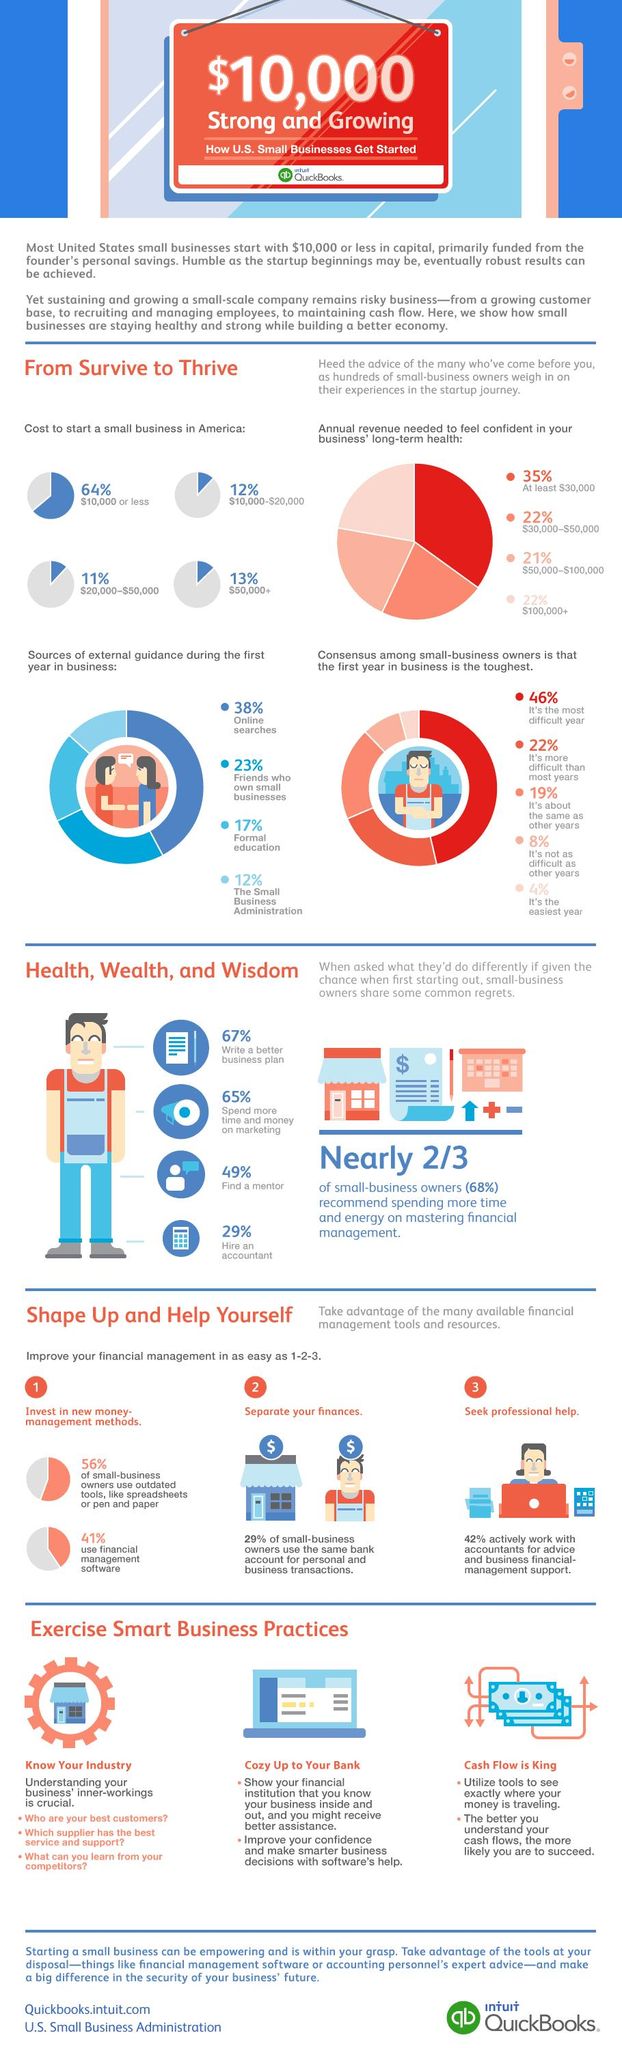Mention a couple of crucial points in this snapshot. Around 12% of businesses require funding between $10,000 and $20,000 to start. Improving your financial management requires taking the second step, which is to separate your finances. A significant percentage of business needs between $10,000 and $50,000 are required to start a business. In the study, it was found that friends who have their own small business often act as sources of external guidance, with 23% of participants reporting this behavior. According to the given information, approximately 13% of businesses require more than $50,000 to start. 